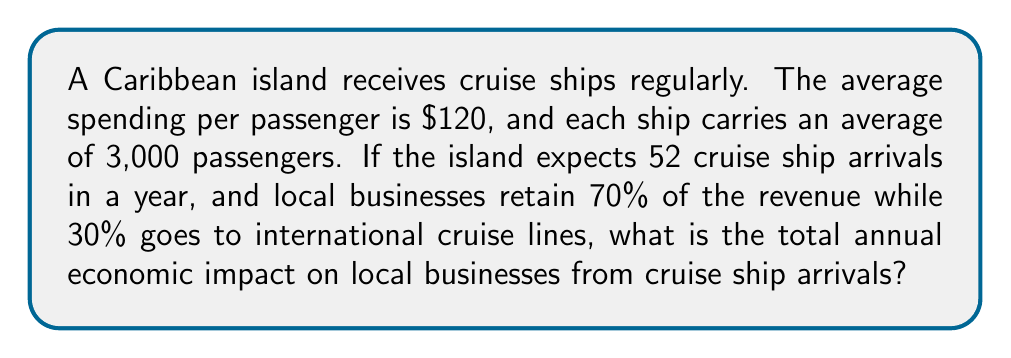What is the answer to this math problem? To solve this problem, we'll follow these steps:

1. Calculate the total spending per cruise ship:
   $$ \text{Spending per ship} = \text{Passengers per ship} \times \text{Spending per passenger} $$
   $$ \text{Spending per ship} = 3,000 \times \$120 = \$360,000 $$

2. Calculate the total annual spending for all cruise ships:
   $$ \text{Annual spending} = \text{Spending per ship} \times \text{Number of arrivals per year} $$
   $$ \text{Annual spending} = \$360,000 \times 52 = \$18,720,000 $$

3. Calculate the portion retained by local businesses:
   $$ \text{Local business revenue} = \text{Annual spending} \times \text{Local retention rate} $$
   $$ \text{Local business revenue} = \$18,720,000 \times 0.70 = \$13,104,000 $$

Therefore, the total annual economic impact on local businesses from cruise ship arrivals is $13,104,000.
Answer: $13,104,000 